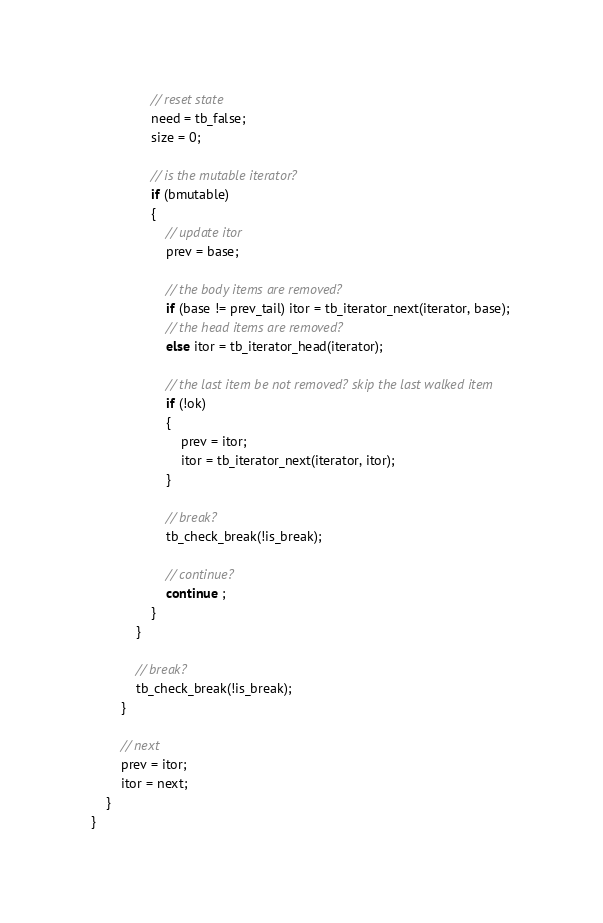Convert code to text. <code><loc_0><loc_0><loc_500><loc_500><_C_>
                // reset state
                need = tb_false;
                size = 0;

                // is the mutable iterator?
                if (bmutable)
                {
                    // update itor
                    prev = base;

                    // the body items are removed?
                    if (base != prev_tail) itor = tb_iterator_next(iterator, base);
                    // the head items are removed?
                    else itor = tb_iterator_head(iterator);

                    // the last item be not removed? skip the last walked item
                    if (!ok)
                    {
                        prev = itor;
                        itor = tb_iterator_next(iterator, itor);
                    }

                    // break?
                    tb_check_break(!is_break);

                    // continue?
                    continue ;
                }
            }

            // break?
            tb_check_break(!is_break);
        }

        // next
        prev = itor;
        itor = next;
    }
}
</code> 